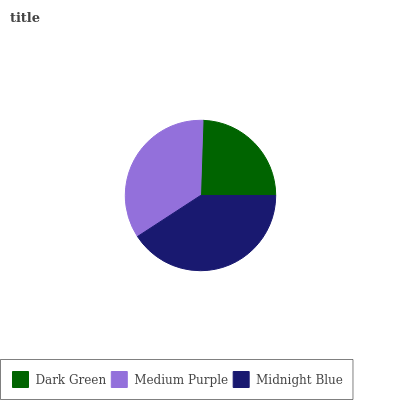Is Dark Green the minimum?
Answer yes or no. Yes. Is Midnight Blue the maximum?
Answer yes or no. Yes. Is Medium Purple the minimum?
Answer yes or no. No. Is Medium Purple the maximum?
Answer yes or no. No. Is Medium Purple greater than Dark Green?
Answer yes or no. Yes. Is Dark Green less than Medium Purple?
Answer yes or no. Yes. Is Dark Green greater than Medium Purple?
Answer yes or no. No. Is Medium Purple less than Dark Green?
Answer yes or no. No. Is Medium Purple the high median?
Answer yes or no. Yes. Is Medium Purple the low median?
Answer yes or no. Yes. Is Dark Green the high median?
Answer yes or no. No. Is Midnight Blue the low median?
Answer yes or no. No. 